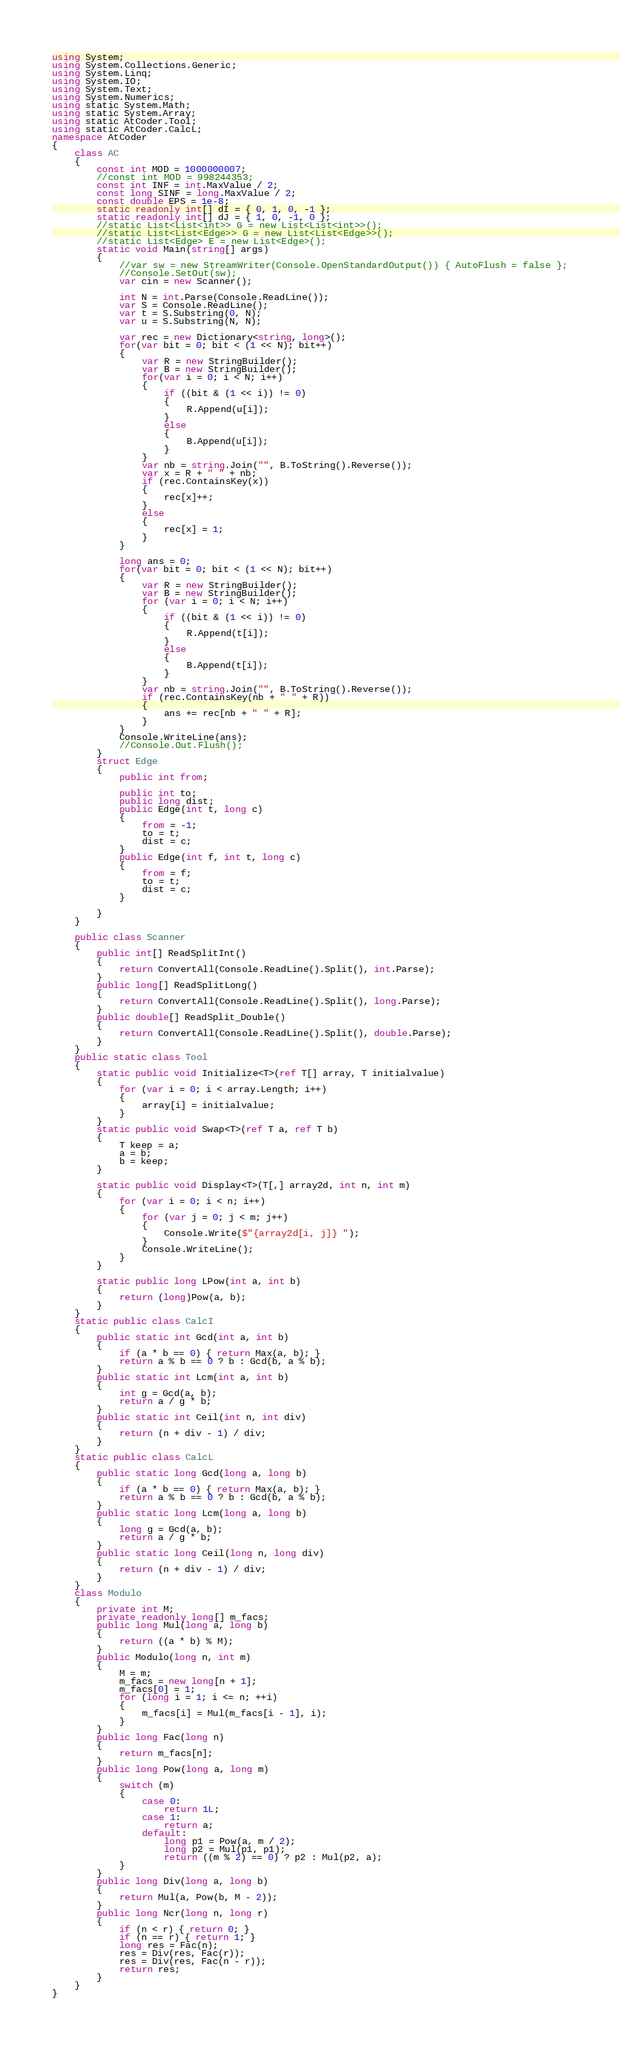Convert code to text. <code><loc_0><loc_0><loc_500><loc_500><_C#_>using System;
using System.Collections.Generic;
using System.Linq;
using System.IO;
using System.Text;
using System.Numerics;
using static System.Math;
using static System.Array;
using static AtCoder.Tool;
using static AtCoder.CalcL;
namespace AtCoder
{
    class AC
    {
        const int MOD = 1000000007;
        //const int MOD = 998244353;
        const int INF = int.MaxValue / 2;
        const long SINF = long.MaxValue / 2;
        const double EPS = 1e-8;
        static readonly int[] dI = { 0, 1, 0, -1 };
        static readonly int[] dJ = { 1, 0, -1, 0 };
        //static List<List<int>> G = new List<List<int>>();
        //static List<List<Edge>> G = new List<List<Edge>>();
        //static List<Edge> E = new List<Edge>();
        static void Main(string[] args)
        {
            //var sw = new StreamWriter(Console.OpenStandardOutput()) { AutoFlush = false };
            //Console.SetOut(sw);
            var cin = new Scanner();

            int N = int.Parse(Console.ReadLine());
            var S = Console.ReadLine();
            var t = S.Substring(0, N);
            var u = S.Substring(N, N);

            var rec = new Dictionary<string, long>();
            for(var bit = 0; bit < (1 << N); bit++)
            {
                var R = new StringBuilder();
                var B = new StringBuilder();
                for(var i = 0; i < N; i++)
                {
                    if ((bit & (1 << i)) != 0)
                    {
                        R.Append(u[i]);
                    }
                    else
                    {
                        B.Append(u[i]);
                    }
                }
                var nb = string.Join("", B.ToString().Reverse());
                var x = R + " " + nb;
                if (rec.ContainsKey(x))
                {
                    rec[x]++;
                }
                else
                {
                    rec[x] = 1;
                }
            }

            long ans = 0;
            for(var bit = 0; bit < (1 << N); bit++)
            {
                var R = new StringBuilder();
                var B = new StringBuilder();
                for (var i = 0; i < N; i++)
                {
                    if ((bit & (1 << i)) != 0)
                    {
                        R.Append(t[i]);
                    }
                    else
                    {
                        B.Append(t[i]);
                    }
                }
                var nb = string.Join("", B.ToString().Reverse());
                if (rec.ContainsKey(nb + " " + R))
                {
                    ans += rec[nb + " " + R];
                }
            }
            Console.WriteLine(ans);
            //Console.Out.Flush();
        }
        struct Edge
        {
            public int from;

            public int to;
            public long dist;
            public Edge(int t, long c)
            {
                from = -1;
                to = t;
                dist = c;
            }
            public Edge(int f, int t, long c)
            {
                from = f;
                to = t;
                dist = c;
            }

        }
    }
    
    public class Scanner
    {
        public int[] ReadSplitInt()
        {
            return ConvertAll(Console.ReadLine().Split(), int.Parse);
        }
        public long[] ReadSplitLong()
        {
            return ConvertAll(Console.ReadLine().Split(), long.Parse);
        }
        public double[] ReadSplit_Double()
        {
            return ConvertAll(Console.ReadLine().Split(), double.Parse);
        }
    }
    public static class Tool
    {
        static public void Initialize<T>(ref T[] array, T initialvalue)
        {
            for (var i = 0; i < array.Length; i++)
            {
                array[i] = initialvalue;
            }
        }
        static public void Swap<T>(ref T a, ref T b)
        {
            T keep = a;
            a = b;
            b = keep;
        }

        static public void Display<T>(T[,] array2d, int n, int m)
        {
            for (var i = 0; i < n; i++)
            {
                for (var j = 0; j < m; j++)
                {
                    Console.Write($"{array2d[i, j]} ");
                }
                Console.WriteLine();
            }
        }

        static public long LPow(int a, int b)
        {
            return (long)Pow(a, b);
        }
    }
    static public class CalcI
    {
        public static int Gcd(int a, int b)
        {
            if (a * b == 0) { return Max(a, b); }
            return a % b == 0 ? b : Gcd(b, a % b);
        }
        public static int Lcm(int a, int b)
        {
            int g = Gcd(a, b);
            return a / g * b;
        }
        public static int Ceil(int n, int div)
        {
            return (n + div - 1) / div;
        }
    }
    static public class CalcL
    {
        public static long Gcd(long a, long b)
        {
            if (a * b == 0) { return Max(a, b); }
            return a % b == 0 ? b : Gcd(b, a % b);
        }
        public static long Lcm(long a, long b)
        {
            long g = Gcd(a, b);
            return a / g * b;
        }
        public static long Ceil(long n, long div)
        {
            return (n + div - 1) / div;
        }
    }
    class Modulo
    {
        private int M;
        private readonly long[] m_facs;
        public long Mul(long a, long b)
        {
            return ((a * b) % M);
        }
        public Modulo(long n, int m)
        {
            M = m;
            m_facs = new long[n + 1];
            m_facs[0] = 1;
            for (long i = 1; i <= n; ++i)
            {
                m_facs[i] = Mul(m_facs[i - 1], i);
            }
        }
        public long Fac(long n)
        {
            return m_facs[n];
        }
        public long Pow(long a, long m)
        {
            switch (m)
            {
                case 0:
                    return 1L;
                case 1:
                    return a;
                default:
                    long p1 = Pow(a, m / 2);
                    long p2 = Mul(p1, p1);
                    return ((m % 2) == 0) ? p2 : Mul(p2, a);
            }
        }
        public long Div(long a, long b)
        {
            return Mul(a, Pow(b, M - 2));
        }
        public long Ncr(long n, long r)
        {
            if (n < r) { return 0; }
            if (n == r) { return 1; }
            long res = Fac(n);
            res = Div(res, Fac(r));
            res = Div(res, Fac(n - r));
            return res;
        }
    }
}
</code> 